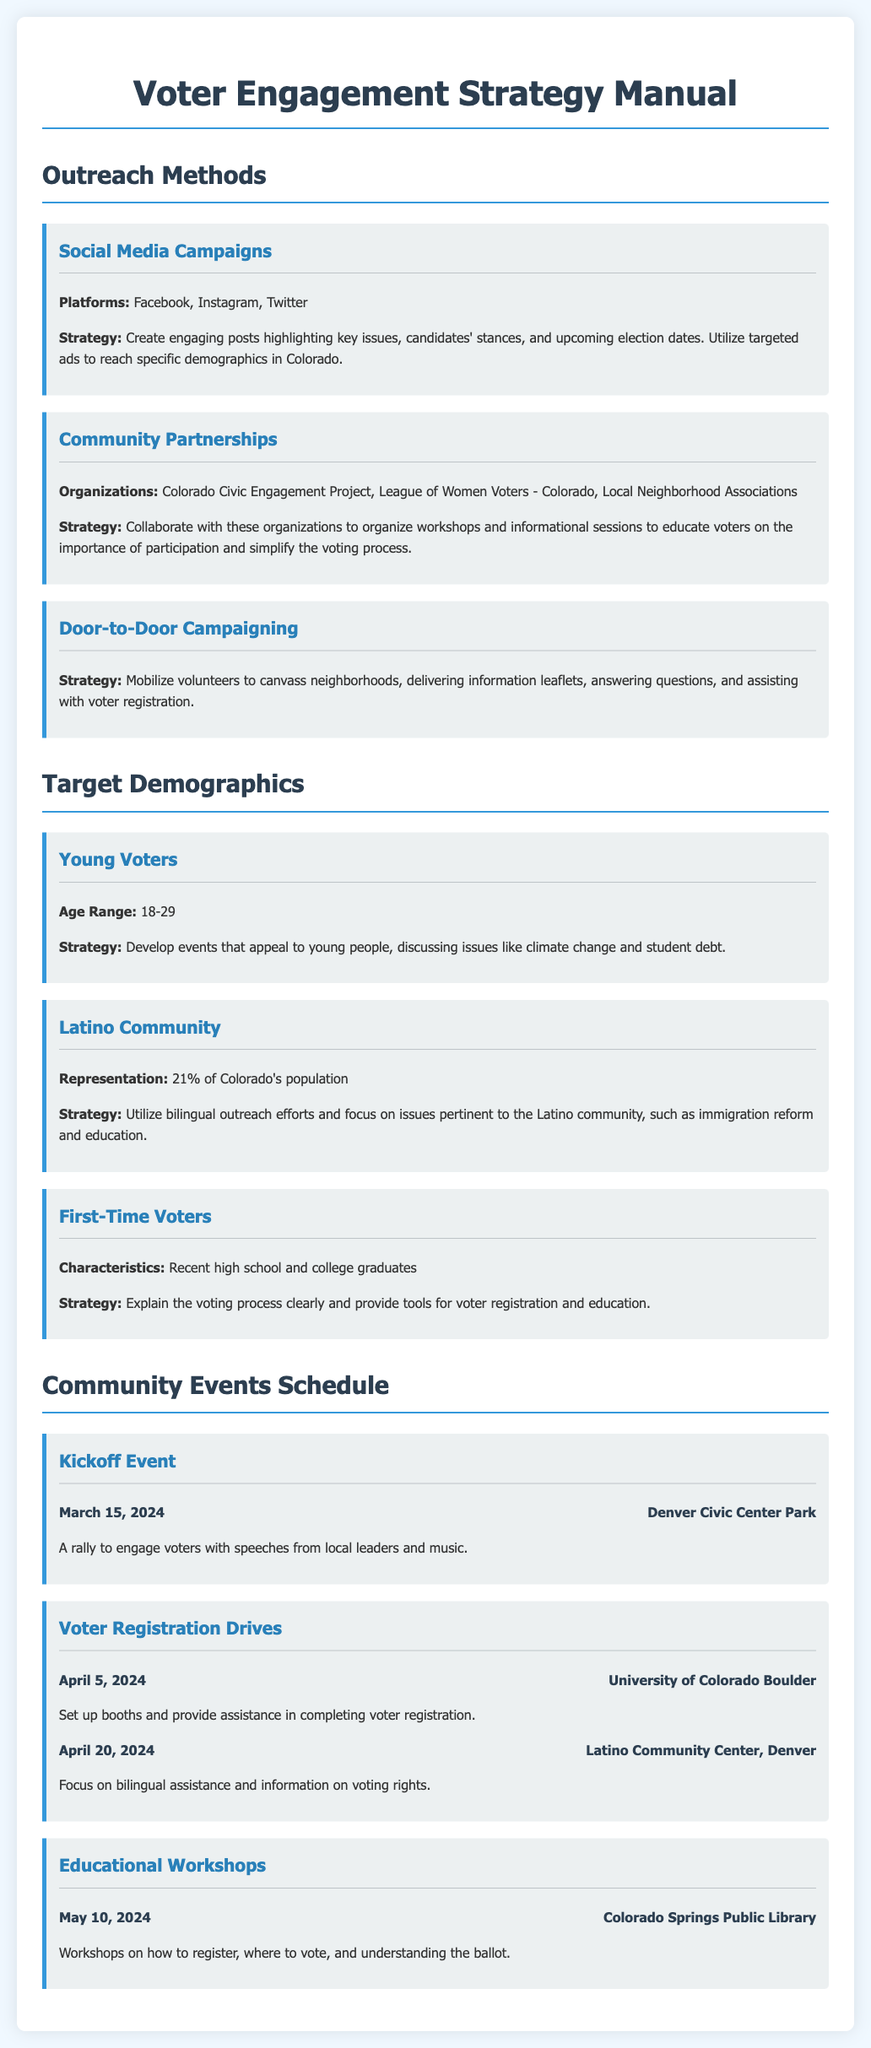What is the title of the manual? The title of the manual is clearly stated at the top of the document.
Answer: Voter Engagement Strategy Manual Which social media platforms are used for outreach? The document lists specific platforms utilized in the outreach methods section.
Answer: Facebook, Instagram, Twitter What date is the kickoff event scheduled? The kickoff event date is specifically mentioned in the community events schedule.
Answer: March 15, 2024 What is the age range of young voters targeted in the strategy? The target demographic for young voters includes a specified age range in the demographics section.
Answer: 18-29 What organization is mentioned for community partnerships? The document provides examples of organizations for community partnerships.
Answer: Colorado Civic Engagement Project How many voter registration drives are listed in the document? The number of voter registration drives can be counted in the community events schedule.
Answer: 2 What type of event is scheduled for May 10, 2024? The document details the type of educational workshop planned on that date.
Answer: Educational Workshops What percentage of Colorado's population is the Latino community? The demographic section states the representation of the Latino community in Colorado.
Answer: 21% What strategy is recommended for first-time voters? The document describes the approach for first-time voters under the target demographics.
Answer: Explain the voting process clearly 